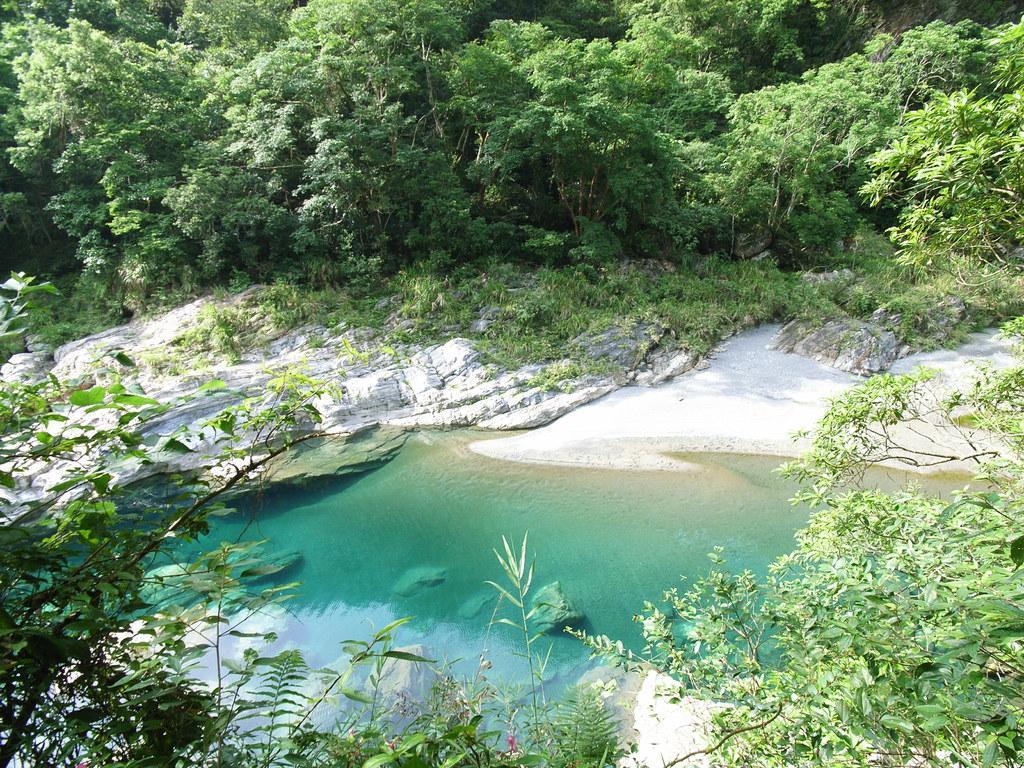Could you give a brief overview of what you see in this image? In the center of the image there is a lake and we can see trees. There are rocks. 